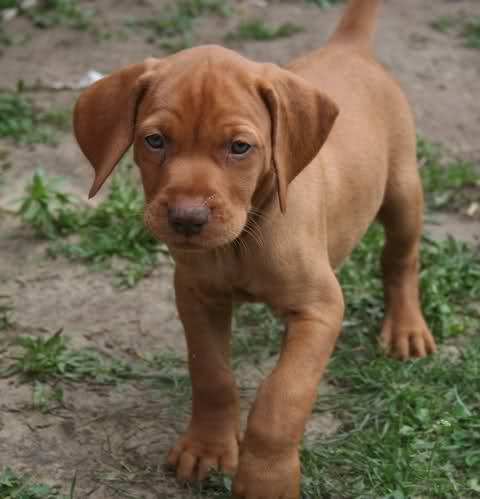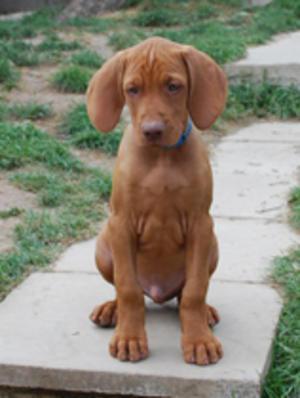The first image is the image on the left, the second image is the image on the right. Evaluate the accuracy of this statement regarding the images: "The left and right image contains the same number of dogs with one puppy and one adult.". Is it true? Answer yes or no. No. The first image is the image on the left, the second image is the image on the right. Considering the images on both sides, is "A dog is wearing a collar." valid? Answer yes or no. Yes. 